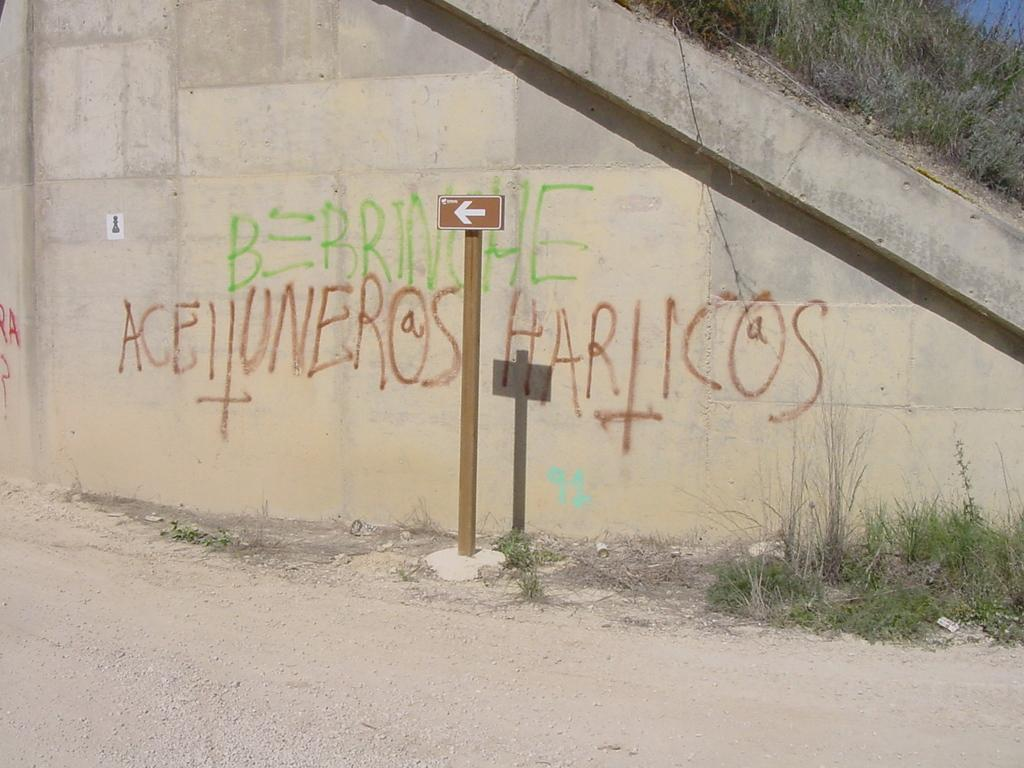What is written or depicted on the wall in the image? There is a wall with text in the image. What is attached to the pole near the wall? There is a pole with a sign board near the wall. What type of vegetation is present on the ground in the image? There is grass on the ground. Is there any grass near the wall? Yes, there is grass near the wall. What type of breakfast is being served on the wall in the image? There is no breakfast present in the image; it features a wall with text and a pole with a sign board. Can you see anyone jumping in the image? There is no one jumping in the image; it shows a wall, a pole with a sign board, and grass on the ground. 